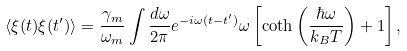Convert formula to latex. <formula><loc_0><loc_0><loc_500><loc_500>\langle \xi ( t ) \xi ( t ^ { \prime } ) \rangle = \frac { \gamma _ { m } } { \omega _ { m } } \int \frac { d \omega } { 2 \pi } e ^ { - i \omega ( t - t ^ { \prime } ) } \omega \left [ \coth \left ( \frac { \hbar { \omega } } { k _ { B } T } \right ) + 1 \right ] ,</formula> 